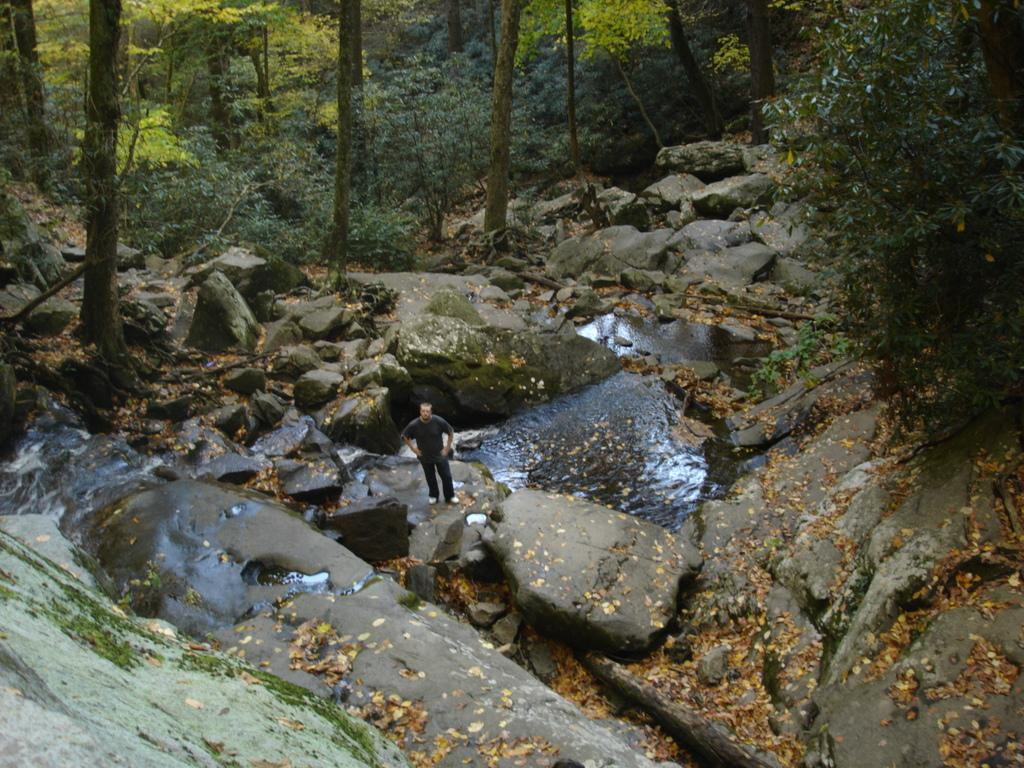What can be seen in the foreground of the image? There are rocks in the foreground of the image. What natural feature is present in the image? There is a river in the image. What type of vegetation is present on either side of the river? There are trees on either side of the river. Can you describe the man's position in the image? A man is standing on a rock in the image. How many geese are swimming in the river in the image? There are no geese present in the image; it features a river with trees on either side and a man standing on a rock. What type of kettle is visible in the image? There is no kettle present in the image. 